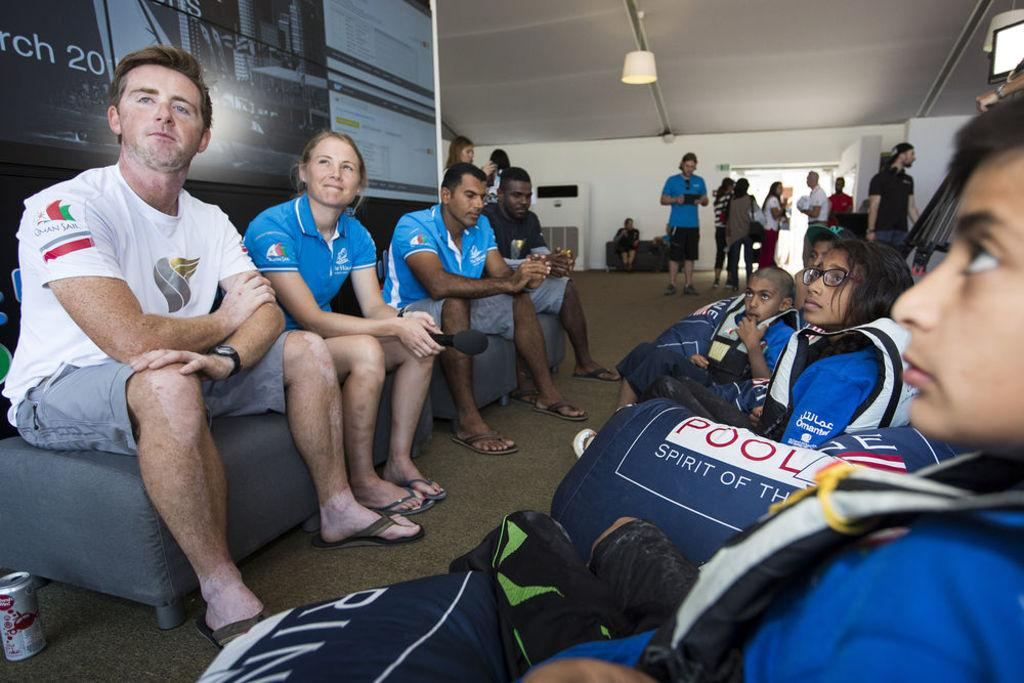Provide a one-sentence caption for the provided image. Children are shown wearing vests and there is a logo that says "Pool.". 